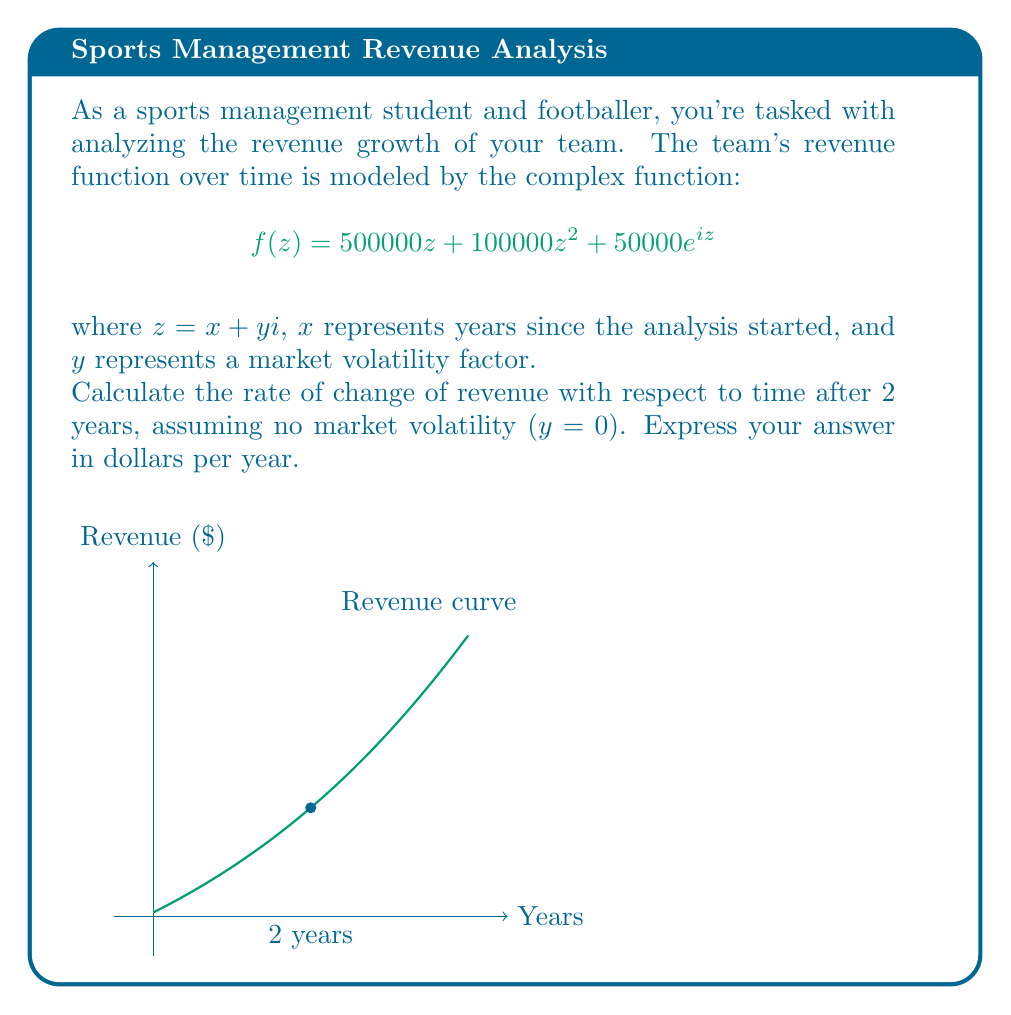Can you answer this question? Let's approach this step-by-step:

1) The given function is $f(z) = 500000z + 100000z^2 + 50000e^{iz}$

2) We need to find $\frac{df}{dx}$ at x = 2 and y = 0

3) First, let's separate the real and imaginary parts:
   $f(x+yi) = 500000(x+yi) + 100000(x+yi)^2 + 50000e^{i(x+yi)}$

4) Expand this:
   $f(x+yi) = (500000x + 500000yi) + (100000x^2 - 100000y^2 + 200000xyi) + 50000e^{ix}e^{-y}$

5) The real part (which represents revenue) is:
   $Re(f) = 500000x + 100000x^2 + 50000e^{-y}\cos(x)$

6) To find the rate of change, we differentiate with respect to x:
   $\frac{d}{dx}Re(f) = 500000 + 200000x - 50000e^{-y}\sin(x)$

7) Now, we substitute x = 2 and y = 0:
   $\frac{d}{dx}Re(f)|_{x=2,y=0} = 500000 + 200000(2) - 50000\sin(2)$

8) Calculate:
   $= 500000 + 400000 - 50000\sin(2)$
   $= 900000 - 45969.77$ (approx.)
   $= 854030.23$ (rounded to 2 decimal places)
Answer: $854,030 per year 